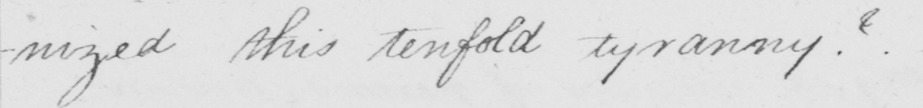Please transcribe the handwritten text in this image. -nized this tenfold tyranny ?   _ 